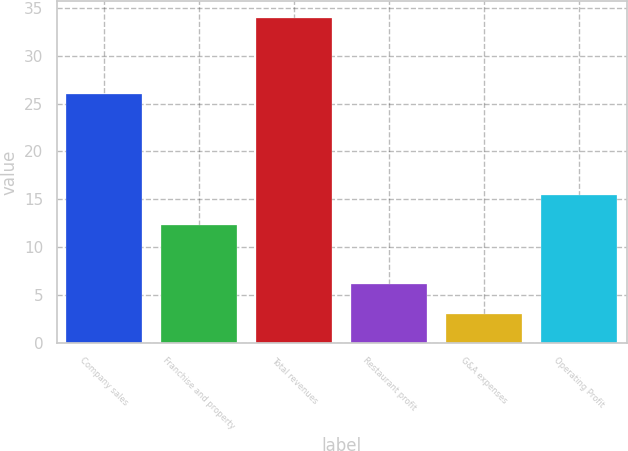Convert chart to OTSL. <chart><loc_0><loc_0><loc_500><loc_500><bar_chart><fcel>Company sales<fcel>Franchise and property<fcel>Total revenues<fcel>Restaurant profit<fcel>G&A expenses<fcel>Operating Profit<nl><fcel>26<fcel>12.3<fcel>34<fcel>6.1<fcel>3<fcel>15.4<nl></chart> 